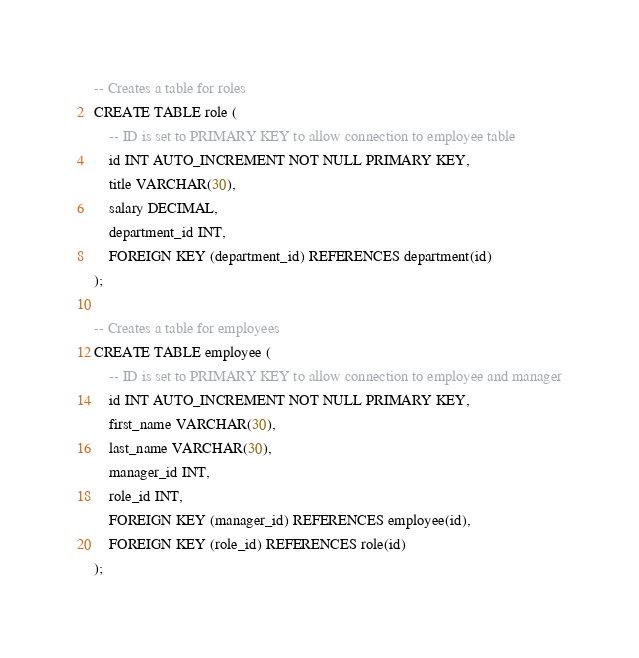<code> <loc_0><loc_0><loc_500><loc_500><_SQL_>
-- Creates a table for roles
CREATE TABLE role (
    -- ID is set to PRIMARY KEY to allow connection to employee table
    id INT AUTO_INCREMENT NOT NULL PRIMARY KEY,
    title VARCHAR(30),
    salary DECIMAL,
    department_id INT,
    FOREIGN KEY (department_id) REFERENCES department(id)
);

-- Creates a table for employees
CREATE TABLE employee (
    -- ID is set to PRIMARY KEY to allow connection to employee and manager
    id INT AUTO_INCREMENT NOT NULL PRIMARY KEY,
    first_name VARCHAR(30),
    last_name VARCHAR(30),
    manager_id INT,
    role_id INT,
    FOREIGN KEY (manager_id) REFERENCES employee(id),
    FOREIGN KEY (role_id) REFERENCES role(id)
);</code> 